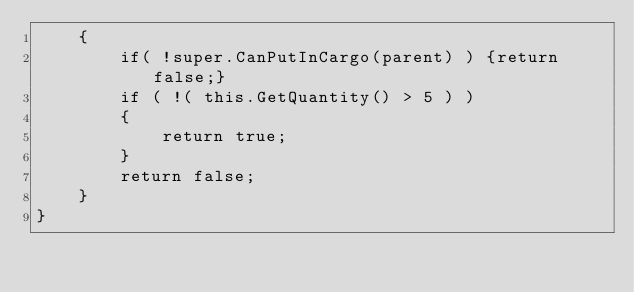Convert code to text. <code><loc_0><loc_0><loc_500><loc_500><_C_>	{
		if( !super.CanPutInCargo(parent) ) {return false;}
		if ( !( this.GetQuantity() > 5 ) )
		{
			return true;
		}
		return false;
	}
}</code> 